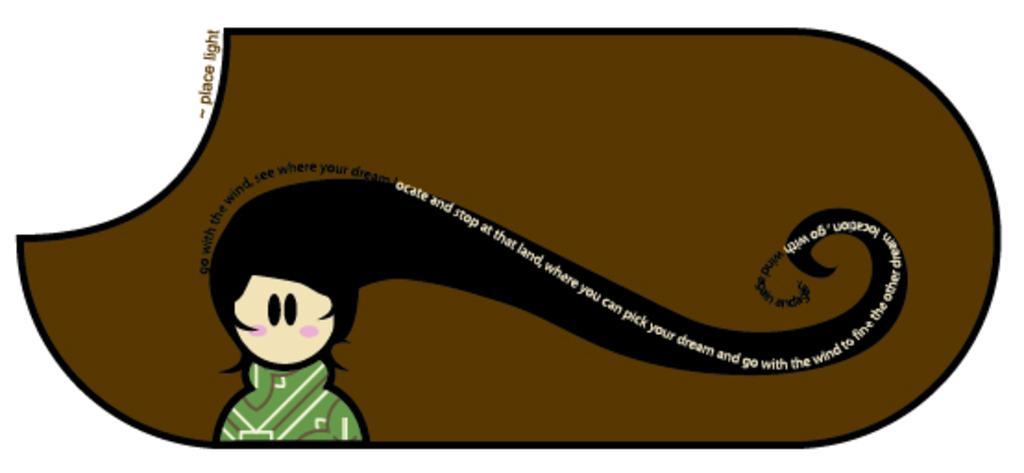Describe this image in one or two sentences. As we can see in the image there is painting of a girl wearing green color dress and there is something written. 